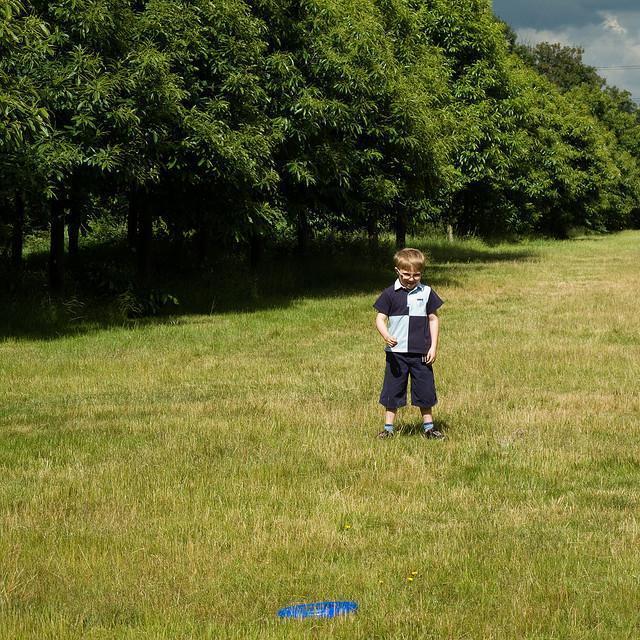How many beds are under the lamp?
Give a very brief answer. 0. 